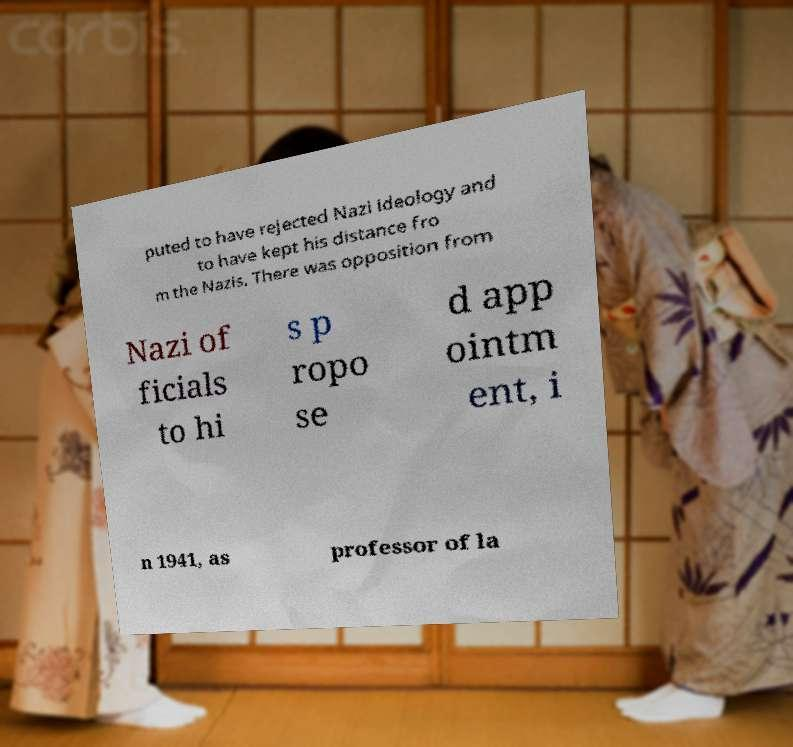I need the written content from this picture converted into text. Can you do that? puted to have rejected Nazi ideology and to have kept his distance fro m the Nazis. There was opposition from Nazi of ficials to hi s p ropo se d app ointm ent, i n 1941, as professor of la 